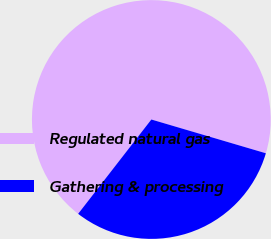Convert chart to OTSL. <chart><loc_0><loc_0><loc_500><loc_500><pie_chart><fcel>Regulated natural gas<fcel>Gathering & processing<nl><fcel>69.06%<fcel>30.94%<nl></chart> 